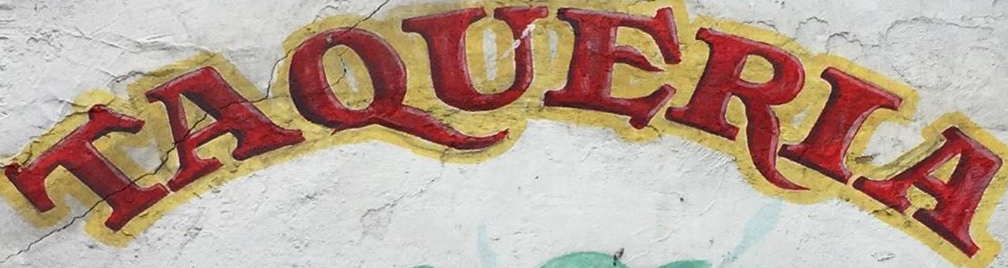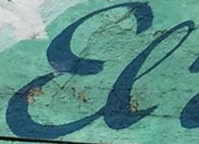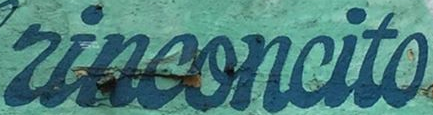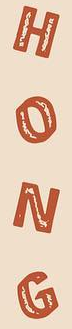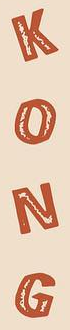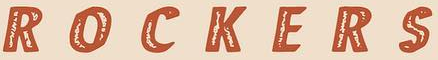What words are shown in these images in order, separated by a semicolon? TAQUERIA; El; rinconcito; HONG; KONG; ROCKERS 